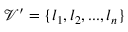<formula> <loc_0><loc_0><loc_500><loc_500>\mathcal { V } ^ { \prime } = \{ l _ { 1 } , l _ { 2 } , \dots , l _ { n } \}</formula> 